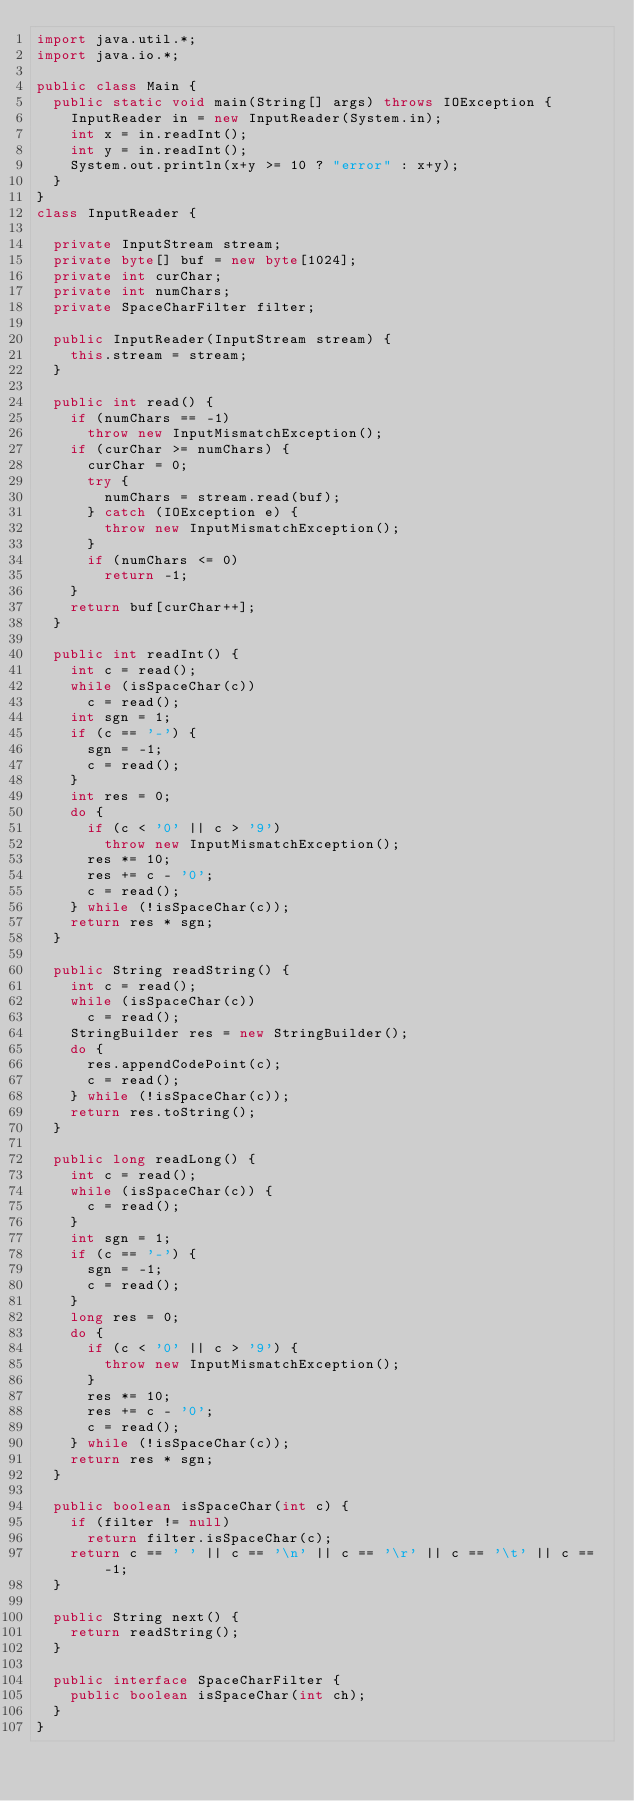<code> <loc_0><loc_0><loc_500><loc_500><_Java_>import java.util.*;
import java.io.*;

public class Main {
	public static void main(String[] args) throws IOException {
		InputReader in = new InputReader(System.in);
		int x = in.readInt();
		int y = in.readInt();
		System.out.println(x+y >= 10 ? "error" : x+y); 
	}
}
class InputReader {

	private InputStream stream;
	private byte[] buf = new byte[1024];
	private int curChar;
	private int numChars;
	private SpaceCharFilter filter;

	public InputReader(InputStream stream) {
		this.stream = stream;
	}

	public int read() {
		if (numChars == -1)
			throw new InputMismatchException();
		if (curChar >= numChars) {
			curChar = 0;
			try {
				numChars = stream.read(buf);
			} catch (IOException e) {
				throw new InputMismatchException();
			}
			if (numChars <= 0)
				return -1;
		}
		return buf[curChar++];
	}

	public int readInt() {
		int c = read();
		while (isSpaceChar(c))
			c = read();
		int sgn = 1;
		if (c == '-') {
			sgn = -1;
			c = read();
		}
		int res = 0;
		do {
			if (c < '0' || c > '9')
				throw new InputMismatchException();
			res *= 10;
			res += c - '0';
			c = read();
		} while (!isSpaceChar(c));
		return res * sgn;
	}

	public String readString() {
		int c = read();
		while (isSpaceChar(c))
			c = read();
		StringBuilder res = new StringBuilder();
		do {
			res.appendCodePoint(c);
			c = read();
		} while (!isSpaceChar(c));
		return res.toString();
	}

	public long readLong() {
		int c = read();
		while (isSpaceChar(c)) {
			c = read();
		}
		int sgn = 1;
		if (c == '-') {
			sgn = -1;
			c = read();
		}
		long res = 0;
		do {
			if (c < '0' || c > '9') {
				throw new InputMismatchException();
			}
			res *= 10;
			res += c - '0';
			c = read();
		} while (!isSpaceChar(c));
		return res * sgn;
	}
	
	public boolean isSpaceChar(int c) {
		if (filter != null)
			return filter.isSpaceChar(c);
		return c == ' ' || c == '\n' || c == '\r' || c == '\t' || c == -1;
	}

	public String next() {
		return readString();
	}

	public interface SpaceCharFilter {
		public boolean isSpaceChar(int ch);
	}
}</code> 